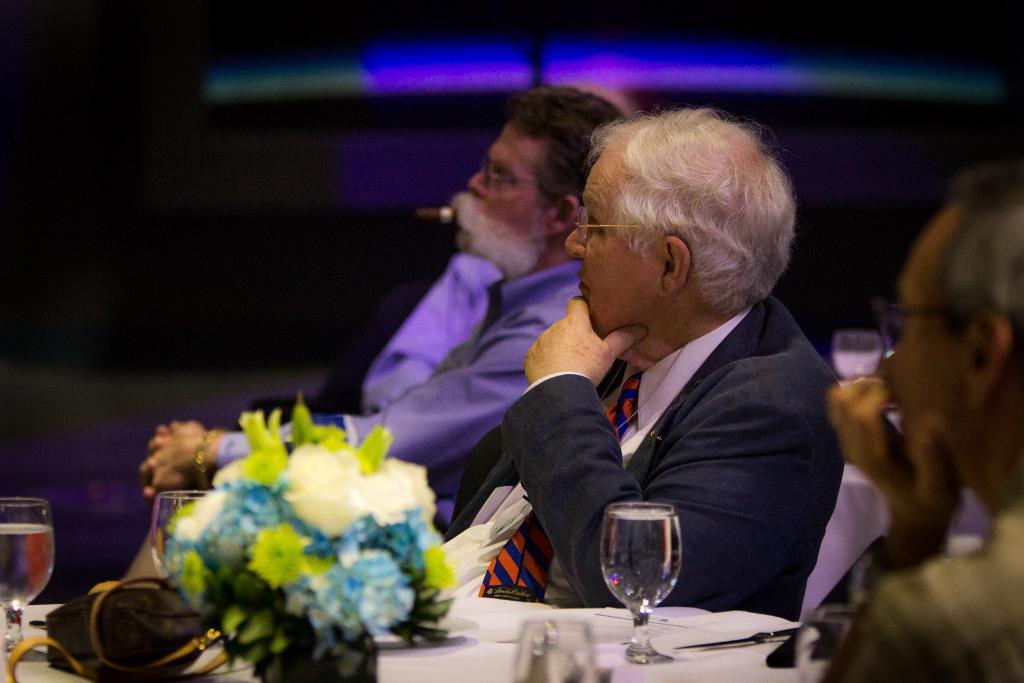Please provide a concise description of this image. In this picture we can see a group of people sitting on chairs and in front of them on tables we can see glasses, flower bouquet, bag and in the background it is dark. 